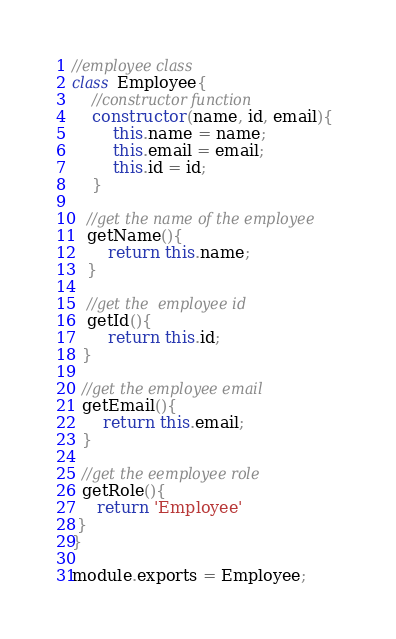<code> <loc_0><loc_0><loc_500><loc_500><_JavaScript_>//employee class
class Employee{
    //constructor function
    constructor(name, id, email){
        this.name = name;
        this.email = email;
        this.id = id;
    }

   //get the name of the employee
   getName(){
       return this.name;
   }
 
   //get the  employee id
   getId(){
       return this.id;
  }

  //get the employee email
  getEmail(){
      return this.email;
  }

  //get the eemployee role
  getRole(){
     return 'Employee'
 }
}

module.exports = Employee;
</code> 